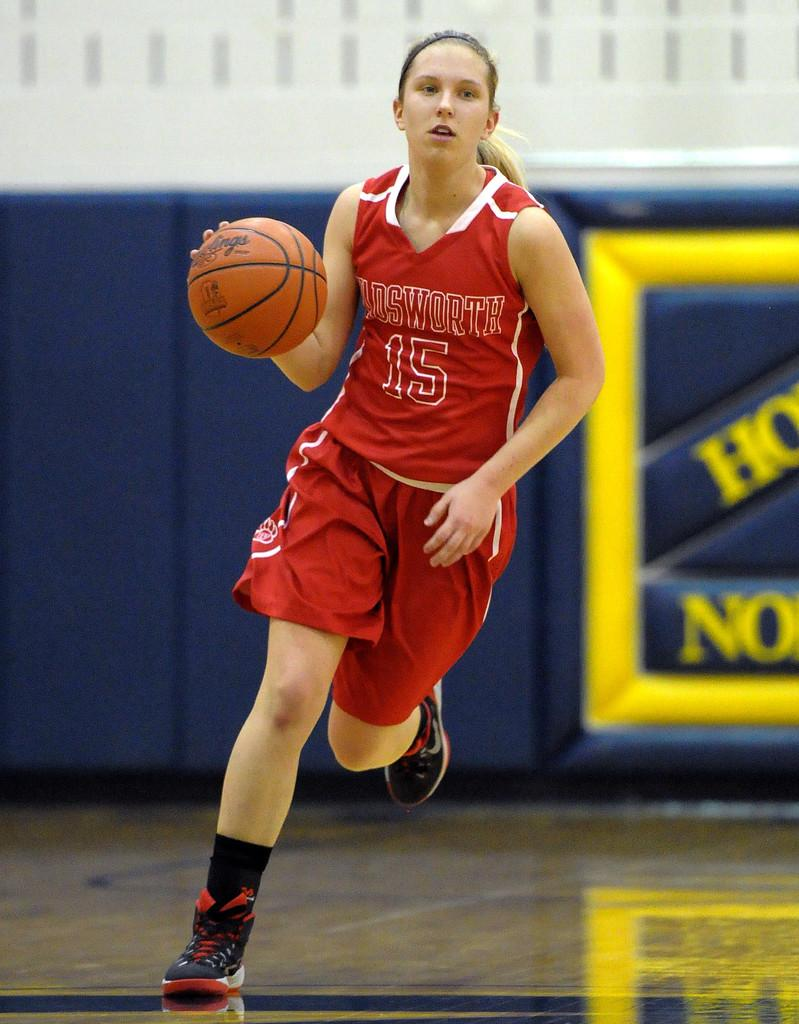Provide a one-sentence caption for the provided image. Basketball player number 15 has the ball and is running. 